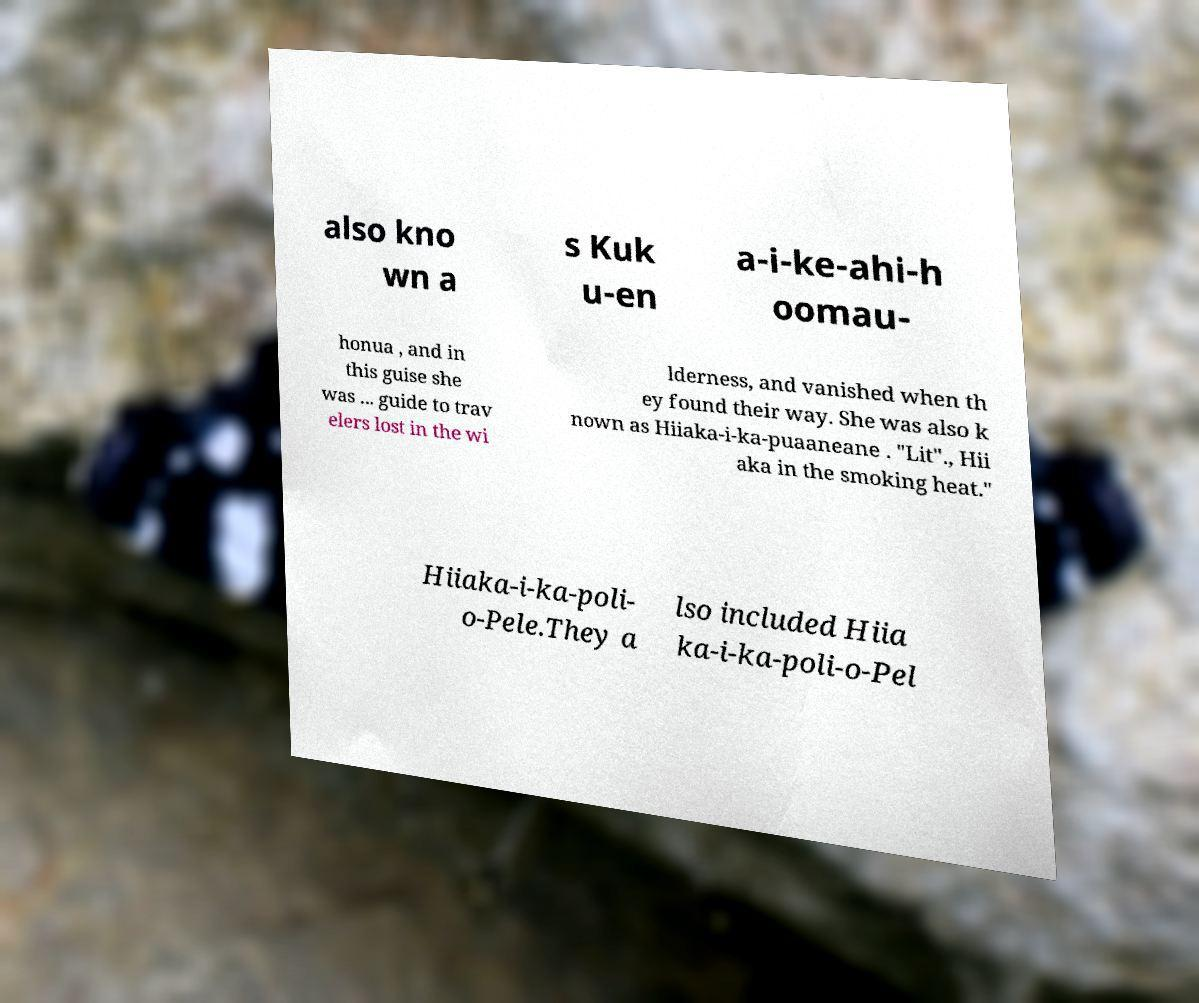Could you extract and type out the text from this image? also kno wn a s Kuk u-en a-i-ke-ahi-h oomau- honua , and in this guise she was ... guide to trav elers lost in the wi lderness, and vanished when th ey found their way. She was also k nown as Hiiaka-i-ka-puaaneane . "Lit"., Hii aka in the smoking heat." Hiiaka-i-ka-poli- o-Pele.They a lso included Hiia ka-i-ka-poli-o-Pel 